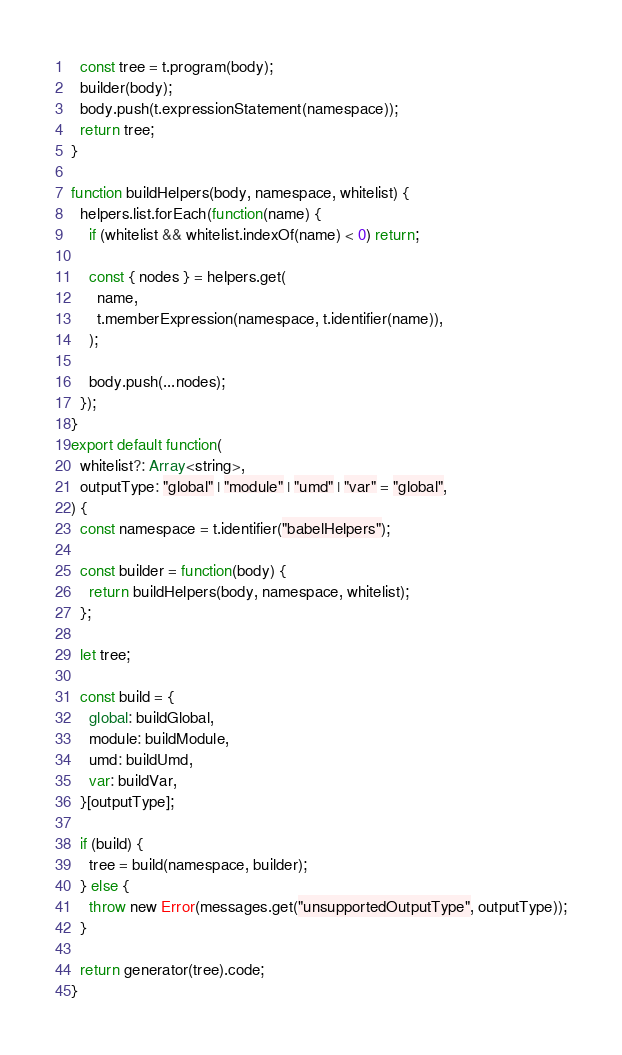Convert code to text. <code><loc_0><loc_0><loc_500><loc_500><_JavaScript_>  const tree = t.program(body);
  builder(body);
  body.push(t.expressionStatement(namespace));
  return tree;
}

function buildHelpers(body, namespace, whitelist) {
  helpers.list.forEach(function(name) {
    if (whitelist && whitelist.indexOf(name) < 0) return;

    const { nodes } = helpers.get(
      name,
      t.memberExpression(namespace, t.identifier(name)),
    );

    body.push(...nodes);
  });
}
export default function(
  whitelist?: Array<string>,
  outputType: "global" | "module" | "umd" | "var" = "global",
) {
  const namespace = t.identifier("babelHelpers");

  const builder = function(body) {
    return buildHelpers(body, namespace, whitelist);
  };

  let tree;

  const build = {
    global: buildGlobal,
    module: buildModule,
    umd: buildUmd,
    var: buildVar,
  }[outputType];

  if (build) {
    tree = build(namespace, builder);
  } else {
    throw new Error(messages.get("unsupportedOutputType", outputType));
  }

  return generator(tree).code;
}
</code> 